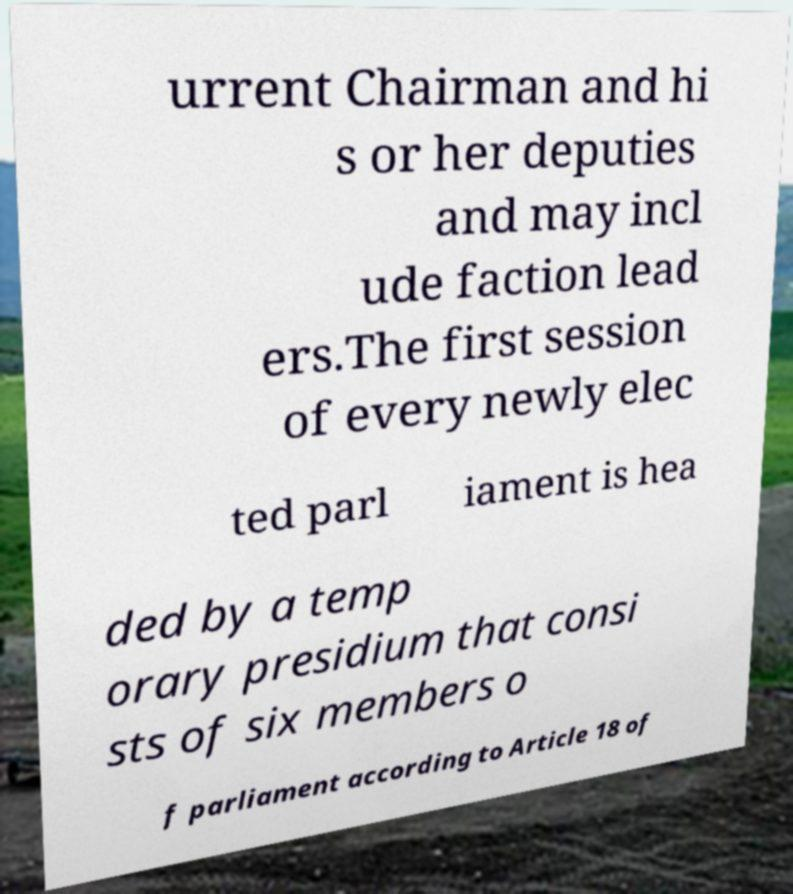What messages or text are displayed in this image? I need them in a readable, typed format. urrent Chairman and hi s or her deputies and may incl ude faction lead ers.The first session of every newly elec ted parl iament is hea ded by a temp orary presidium that consi sts of six members o f parliament according to Article 18 of 